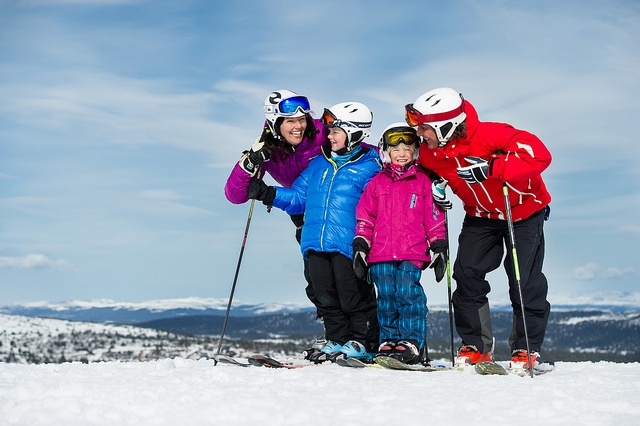Describe the objects in this image and their specific colors. I can see people in darkgray, black, red, brown, and lightgray tones, people in darkgray, black, blue, gray, and white tones, people in darkgray, purple, magenta, black, and navy tones, people in darkgray, black, purple, and lightgray tones, and skis in darkgray, gray, lightgray, and olive tones in this image. 